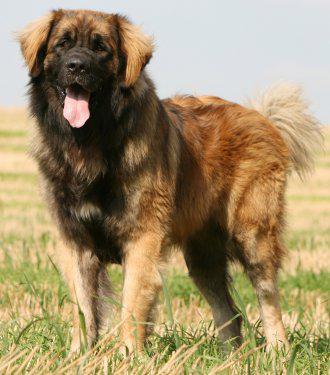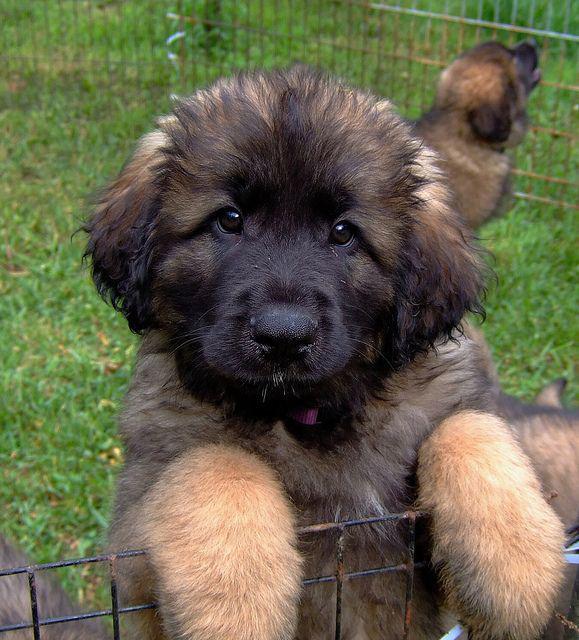The first image is the image on the left, the second image is the image on the right. For the images shown, is this caption "There is one dog tongue in the image on the left." true? Answer yes or no. Yes. 